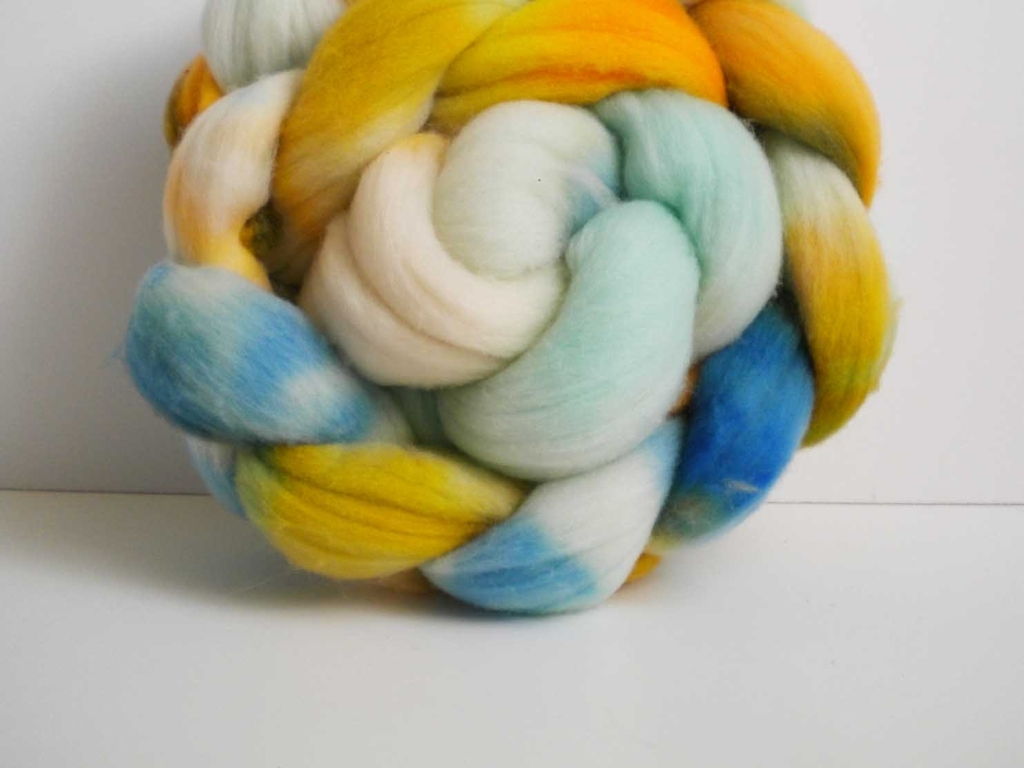What might be a creative project one could undertake using this material? One creative project using this wool roving could be hand-spinning it into yarn and then knitting or weaving it into a one-of-a-kind scarf or beanie. Alternatively, the roving can be needle felted into 3D art or figures, showing off the beautiful colors in a textural piece. 